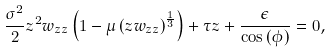Convert formula to latex. <formula><loc_0><loc_0><loc_500><loc_500>\frac { \sigma ^ { 2 } } { 2 } z ^ { 2 } w _ { z z } \left ( 1 - \mu \left ( z w _ { z z } \right ) ^ { \frac { 1 } { 3 } } \right ) + \tau z + \frac { \epsilon } { \cos { ( \phi ) } } = 0 ,</formula> 